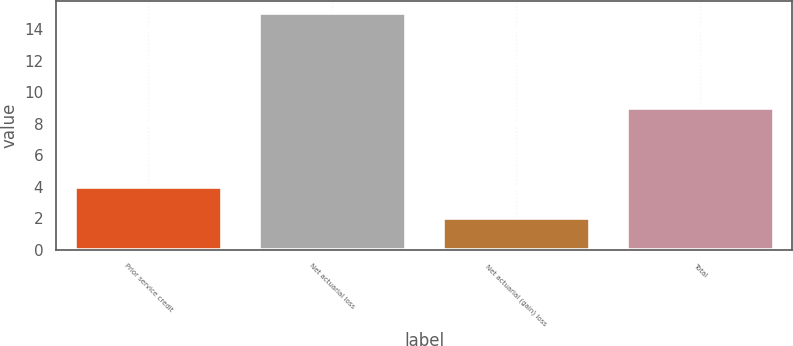<chart> <loc_0><loc_0><loc_500><loc_500><bar_chart><fcel>Prior service credit<fcel>Net actuarial loss<fcel>Net actuarial (gain) loss<fcel>Total<nl><fcel>4<fcel>15<fcel>2<fcel>9<nl></chart> 